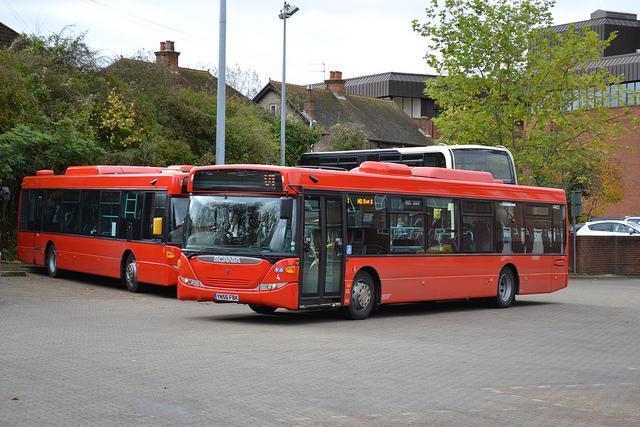How many buses are immediately seen?
Give a very brief answer. 3. How many buses are under the overhang?
Give a very brief answer. 3. How many buses are in the photo?
Give a very brief answer. 3. 